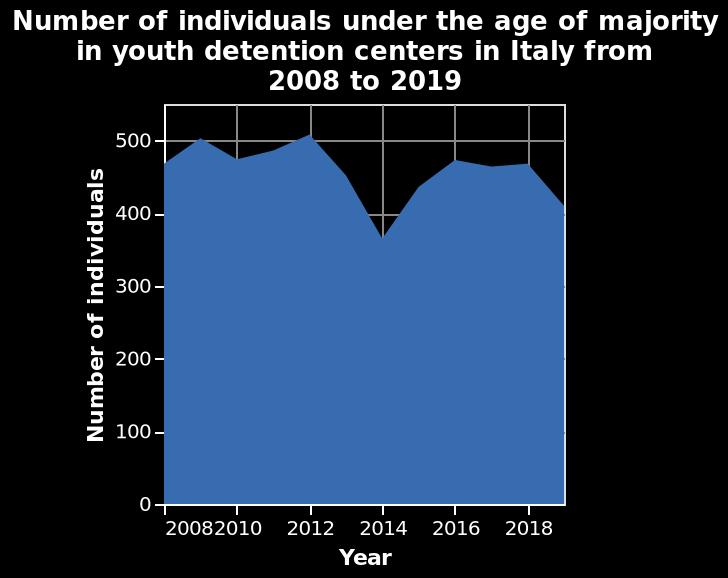<image>
What does "under the age of majority" refer to in this figure? It refers to individuals who have not reached the legal age of adulthood. What is the range of values represented on the y-axis? The y-axis represents values from 0 to 500. How many individuals under the age of majority were there in 2014?  It is not specified in the given information. During which year did the market share growth rate reach its peak?  2014 